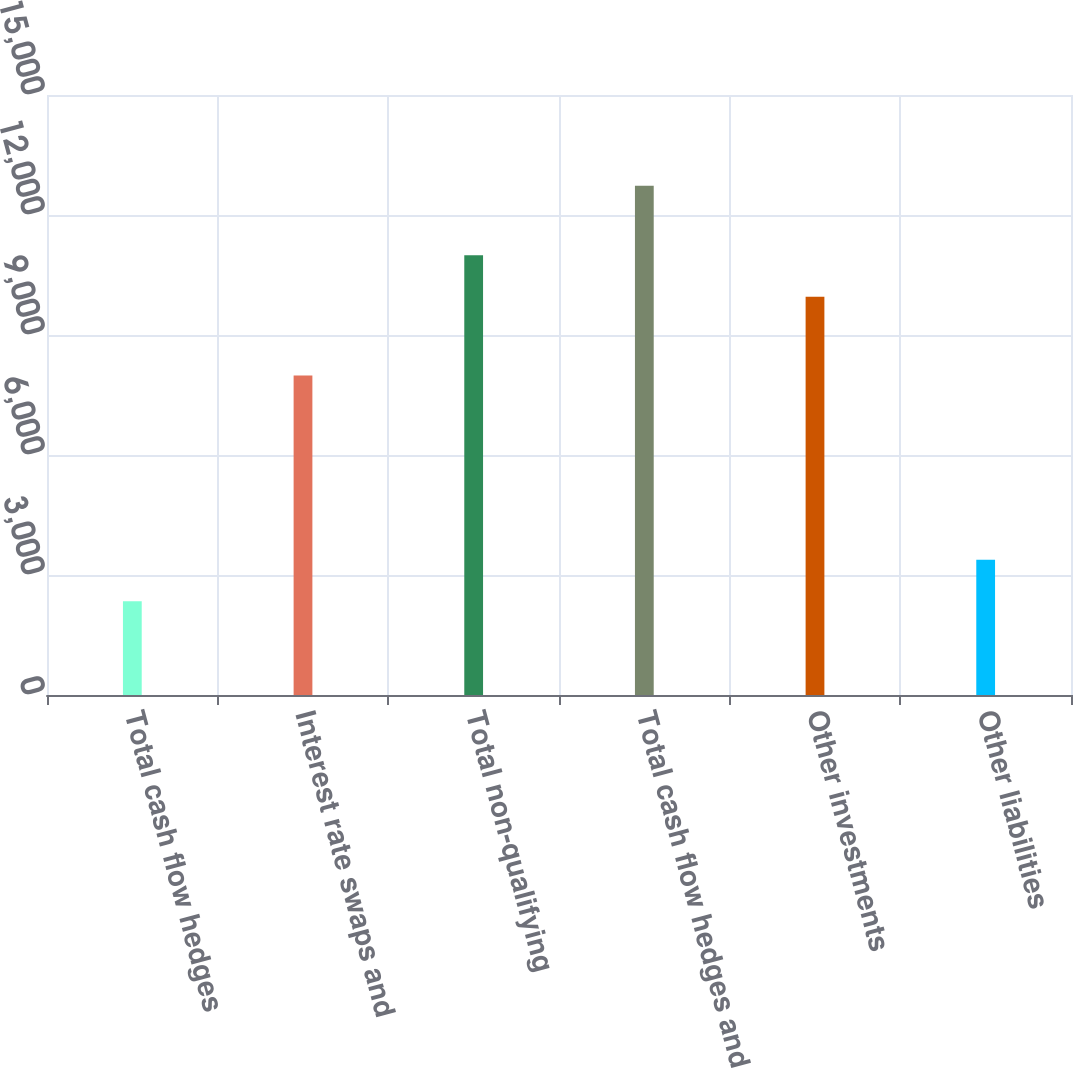Convert chart to OTSL. <chart><loc_0><loc_0><loc_500><loc_500><bar_chart><fcel>Total cash flow hedges<fcel>Interest rate swaps and<fcel>Total non-qualifying<fcel>Total cash flow hedges and<fcel>Other investments<fcel>Other liabilities<nl><fcel>2343<fcel>7986<fcel>10995.7<fcel>12730<fcel>9957<fcel>3381.7<nl></chart> 